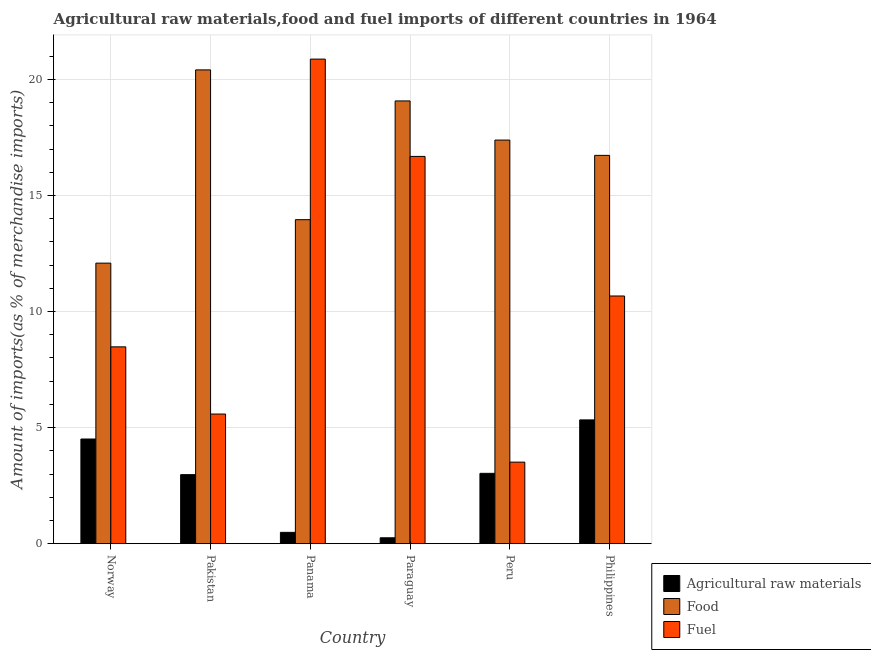How many groups of bars are there?
Your response must be concise. 6. Are the number of bars on each tick of the X-axis equal?
Offer a very short reply. Yes. What is the label of the 4th group of bars from the left?
Provide a succinct answer. Paraguay. What is the percentage of food imports in Norway?
Ensure brevity in your answer.  12.08. Across all countries, what is the maximum percentage of fuel imports?
Provide a short and direct response. 20.87. Across all countries, what is the minimum percentage of food imports?
Your answer should be compact. 12.08. In which country was the percentage of raw materials imports minimum?
Your answer should be very brief. Paraguay. What is the total percentage of food imports in the graph?
Your response must be concise. 99.63. What is the difference between the percentage of raw materials imports in Norway and that in Peru?
Offer a very short reply. 1.48. What is the difference between the percentage of raw materials imports in Paraguay and the percentage of food imports in Philippines?
Offer a terse response. -16.47. What is the average percentage of food imports per country?
Give a very brief answer. 16.61. What is the difference between the percentage of food imports and percentage of raw materials imports in Norway?
Make the answer very short. 7.58. What is the ratio of the percentage of food imports in Pakistan to that in Paraguay?
Keep it short and to the point. 1.07. Is the difference between the percentage of raw materials imports in Pakistan and Peru greater than the difference between the percentage of fuel imports in Pakistan and Peru?
Ensure brevity in your answer.  No. What is the difference between the highest and the second highest percentage of raw materials imports?
Keep it short and to the point. 0.82. What is the difference between the highest and the lowest percentage of food imports?
Your response must be concise. 8.32. What does the 2nd bar from the left in Philippines represents?
Make the answer very short. Food. What does the 2nd bar from the right in Norway represents?
Ensure brevity in your answer.  Food. Is it the case that in every country, the sum of the percentage of raw materials imports and percentage of food imports is greater than the percentage of fuel imports?
Offer a very short reply. No. Are all the bars in the graph horizontal?
Provide a short and direct response. No. How many countries are there in the graph?
Make the answer very short. 6. Are the values on the major ticks of Y-axis written in scientific E-notation?
Your answer should be compact. No. Does the graph contain grids?
Provide a short and direct response. Yes. What is the title of the graph?
Offer a terse response. Agricultural raw materials,food and fuel imports of different countries in 1964. What is the label or title of the X-axis?
Give a very brief answer. Country. What is the label or title of the Y-axis?
Your response must be concise. Amount of imports(as % of merchandise imports). What is the Amount of imports(as % of merchandise imports) of Agricultural raw materials in Norway?
Offer a very short reply. 4.51. What is the Amount of imports(as % of merchandise imports) in Food in Norway?
Your answer should be very brief. 12.08. What is the Amount of imports(as % of merchandise imports) of Fuel in Norway?
Ensure brevity in your answer.  8.48. What is the Amount of imports(as % of merchandise imports) in Agricultural raw materials in Pakistan?
Offer a very short reply. 2.97. What is the Amount of imports(as % of merchandise imports) of Food in Pakistan?
Offer a very short reply. 20.41. What is the Amount of imports(as % of merchandise imports) in Fuel in Pakistan?
Make the answer very short. 5.58. What is the Amount of imports(as % of merchandise imports) in Agricultural raw materials in Panama?
Offer a terse response. 0.49. What is the Amount of imports(as % of merchandise imports) in Food in Panama?
Offer a very short reply. 13.96. What is the Amount of imports(as % of merchandise imports) of Fuel in Panama?
Keep it short and to the point. 20.87. What is the Amount of imports(as % of merchandise imports) in Agricultural raw materials in Paraguay?
Offer a very short reply. 0.25. What is the Amount of imports(as % of merchandise imports) of Food in Paraguay?
Give a very brief answer. 19.07. What is the Amount of imports(as % of merchandise imports) in Fuel in Paraguay?
Provide a succinct answer. 16.68. What is the Amount of imports(as % of merchandise imports) of Agricultural raw materials in Peru?
Your answer should be compact. 3.03. What is the Amount of imports(as % of merchandise imports) of Food in Peru?
Make the answer very short. 17.39. What is the Amount of imports(as % of merchandise imports) in Fuel in Peru?
Keep it short and to the point. 3.51. What is the Amount of imports(as % of merchandise imports) in Agricultural raw materials in Philippines?
Provide a succinct answer. 5.33. What is the Amount of imports(as % of merchandise imports) of Food in Philippines?
Ensure brevity in your answer.  16.73. What is the Amount of imports(as % of merchandise imports) of Fuel in Philippines?
Give a very brief answer. 10.67. Across all countries, what is the maximum Amount of imports(as % of merchandise imports) in Agricultural raw materials?
Keep it short and to the point. 5.33. Across all countries, what is the maximum Amount of imports(as % of merchandise imports) in Food?
Make the answer very short. 20.41. Across all countries, what is the maximum Amount of imports(as % of merchandise imports) in Fuel?
Make the answer very short. 20.87. Across all countries, what is the minimum Amount of imports(as % of merchandise imports) in Agricultural raw materials?
Give a very brief answer. 0.25. Across all countries, what is the minimum Amount of imports(as % of merchandise imports) of Food?
Give a very brief answer. 12.08. Across all countries, what is the minimum Amount of imports(as % of merchandise imports) of Fuel?
Offer a very short reply. 3.51. What is the total Amount of imports(as % of merchandise imports) in Agricultural raw materials in the graph?
Make the answer very short. 16.58. What is the total Amount of imports(as % of merchandise imports) of Food in the graph?
Your answer should be compact. 99.63. What is the total Amount of imports(as % of merchandise imports) of Fuel in the graph?
Offer a very short reply. 65.8. What is the difference between the Amount of imports(as % of merchandise imports) in Agricultural raw materials in Norway and that in Pakistan?
Your answer should be compact. 1.53. What is the difference between the Amount of imports(as % of merchandise imports) of Food in Norway and that in Pakistan?
Make the answer very short. -8.32. What is the difference between the Amount of imports(as % of merchandise imports) of Fuel in Norway and that in Pakistan?
Keep it short and to the point. 2.89. What is the difference between the Amount of imports(as % of merchandise imports) in Agricultural raw materials in Norway and that in Panama?
Ensure brevity in your answer.  4.02. What is the difference between the Amount of imports(as % of merchandise imports) of Food in Norway and that in Panama?
Provide a short and direct response. -1.87. What is the difference between the Amount of imports(as % of merchandise imports) of Fuel in Norway and that in Panama?
Offer a terse response. -12.4. What is the difference between the Amount of imports(as % of merchandise imports) of Agricultural raw materials in Norway and that in Paraguay?
Provide a succinct answer. 4.26. What is the difference between the Amount of imports(as % of merchandise imports) of Food in Norway and that in Paraguay?
Offer a very short reply. -6.99. What is the difference between the Amount of imports(as % of merchandise imports) in Fuel in Norway and that in Paraguay?
Offer a terse response. -8.2. What is the difference between the Amount of imports(as % of merchandise imports) in Agricultural raw materials in Norway and that in Peru?
Ensure brevity in your answer.  1.48. What is the difference between the Amount of imports(as % of merchandise imports) of Food in Norway and that in Peru?
Provide a succinct answer. -5.3. What is the difference between the Amount of imports(as % of merchandise imports) of Fuel in Norway and that in Peru?
Your response must be concise. 4.97. What is the difference between the Amount of imports(as % of merchandise imports) of Agricultural raw materials in Norway and that in Philippines?
Keep it short and to the point. -0.82. What is the difference between the Amount of imports(as % of merchandise imports) in Food in Norway and that in Philippines?
Your answer should be very brief. -4.64. What is the difference between the Amount of imports(as % of merchandise imports) in Fuel in Norway and that in Philippines?
Give a very brief answer. -2.19. What is the difference between the Amount of imports(as % of merchandise imports) in Agricultural raw materials in Pakistan and that in Panama?
Give a very brief answer. 2.49. What is the difference between the Amount of imports(as % of merchandise imports) in Food in Pakistan and that in Panama?
Your answer should be compact. 6.45. What is the difference between the Amount of imports(as % of merchandise imports) of Fuel in Pakistan and that in Panama?
Give a very brief answer. -15.29. What is the difference between the Amount of imports(as % of merchandise imports) of Agricultural raw materials in Pakistan and that in Paraguay?
Your answer should be very brief. 2.72. What is the difference between the Amount of imports(as % of merchandise imports) of Food in Pakistan and that in Paraguay?
Your answer should be compact. 1.34. What is the difference between the Amount of imports(as % of merchandise imports) of Fuel in Pakistan and that in Paraguay?
Provide a short and direct response. -11.1. What is the difference between the Amount of imports(as % of merchandise imports) of Agricultural raw materials in Pakistan and that in Peru?
Offer a terse response. -0.06. What is the difference between the Amount of imports(as % of merchandise imports) in Food in Pakistan and that in Peru?
Your response must be concise. 3.02. What is the difference between the Amount of imports(as % of merchandise imports) in Fuel in Pakistan and that in Peru?
Your answer should be very brief. 2.07. What is the difference between the Amount of imports(as % of merchandise imports) of Agricultural raw materials in Pakistan and that in Philippines?
Your response must be concise. -2.36. What is the difference between the Amount of imports(as % of merchandise imports) of Food in Pakistan and that in Philippines?
Give a very brief answer. 3.68. What is the difference between the Amount of imports(as % of merchandise imports) of Fuel in Pakistan and that in Philippines?
Make the answer very short. -5.09. What is the difference between the Amount of imports(as % of merchandise imports) of Agricultural raw materials in Panama and that in Paraguay?
Offer a very short reply. 0.23. What is the difference between the Amount of imports(as % of merchandise imports) in Food in Panama and that in Paraguay?
Your answer should be compact. -5.12. What is the difference between the Amount of imports(as % of merchandise imports) of Fuel in Panama and that in Paraguay?
Keep it short and to the point. 4.19. What is the difference between the Amount of imports(as % of merchandise imports) in Agricultural raw materials in Panama and that in Peru?
Your answer should be very brief. -2.54. What is the difference between the Amount of imports(as % of merchandise imports) in Food in Panama and that in Peru?
Make the answer very short. -3.43. What is the difference between the Amount of imports(as % of merchandise imports) of Fuel in Panama and that in Peru?
Your answer should be very brief. 17.36. What is the difference between the Amount of imports(as % of merchandise imports) of Agricultural raw materials in Panama and that in Philippines?
Your response must be concise. -4.84. What is the difference between the Amount of imports(as % of merchandise imports) in Food in Panama and that in Philippines?
Provide a short and direct response. -2.77. What is the difference between the Amount of imports(as % of merchandise imports) in Fuel in Panama and that in Philippines?
Keep it short and to the point. 10.2. What is the difference between the Amount of imports(as % of merchandise imports) in Agricultural raw materials in Paraguay and that in Peru?
Provide a short and direct response. -2.78. What is the difference between the Amount of imports(as % of merchandise imports) of Food in Paraguay and that in Peru?
Make the answer very short. 1.69. What is the difference between the Amount of imports(as % of merchandise imports) in Fuel in Paraguay and that in Peru?
Provide a short and direct response. 13.17. What is the difference between the Amount of imports(as % of merchandise imports) of Agricultural raw materials in Paraguay and that in Philippines?
Offer a very short reply. -5.08. What is the difference between the Amount of imports(as % of merchandise imports) of Food in Paraguay and that in Philippines?
Your response must be concise. 2.35. What is the difference between the Amount of imports(as % of merchandise imports) in Fuel in Paraguay and that in Philippines?
Ensure brevity in your answer.  6.01. What is the difference between the Amount of imports(as % of merchandise imports) of Agricultural raw materials in Peru and that in Philippines?
Your response must be concise. -2.3. What is the difference between the Amount of imports(as % of merchandise imports) of Food in Peru and that in Philippines?
Ensure brevity in your answer.  0.66. What is the difference between the Amount of imports(as % of merchandise imports) in Fuel in Peru and that in Philippines?
Your answer should be compact. -7.16. What is the difference between the Amount of imports(as % of merchandise imports) in Agricultural raw materials in Norway and the Amount of imports(as % of merchandise imports) in Food in Pakistan?
Your answer should be very brief. -15.9. What is the difference between the Amount of imports(as % of merchandise imports) in Agricultural raw materials in Norway and the Amount of imports(as % of merchandise imports) in Fuel in Pakistan?
Give a very brief answer. -1.08. What is the difference between the Amount of imports(as % of merchandise imports) in Food in Norway and the Amount of imports(as % of merchandise imports) in Fuel in Pakistan?
Give a very brief answer. 6.5. What is the difference between the Amount of imports(as % of merchandise imports) of Agricultural raw materials in Norway and the Amount of imports(as % of merchandise imports) of Food in Panama?
Provide a succinct answer. -9.45. What is the difference between the Amount of imports(as % of merchandise imports) of Agricultural raw materials in Norway and the Amount of imports(as % of merchandise imports) of Fuel in Panama?
Your answer should be compact. -16.37. What is the difference between the Amount of imports(as % of merchandise imports) of Food in Norway and the Amount of imports(as % of merchandise imports) of Fuel in Panama?
Your response must be concise. -8.79. What is the difference between the Amount of imports(as % of merchandise imports) in Agricultural raw materials in Norway and the Amount of imports(as % of merchandise imports) in Food in Paraguay?
Your response must be concise. -14.56. What is the difference between the Amount of imports(as % of merchandise imports) in Agricultural raw materials in Norway and the Amount of imports(as % of merchandise imports) in Fuel in Paraguay?
Your response must be concise. -12.17. What is the difference between the Amount of imports(as % of merchandise imports) of Food in Norway and the Amount of imports(as % of merchandise imports) of Fuel in Paraguay?
Make the answer very short. -4.6. What is the difference between the Amount of imports(as % of merchandise imports) of Agricultural raw materials in Norway and the Amount of imports(as % of merchandise imports) of Food in Peru?
Your response must be concise. -12.88. What is the difference between the Amount of imports(as % of merchandise imports) in Food in Norway and the Amount of imports(as % of merchandise imports) in Fuel in Peru?
Ensure brevity in your answer.  8.57. What is the difference between the Amount of imports(as % of merchandise imports) in Agricultural raw materials in Norway and the Amount of imports(as % of merchandise imports) in Food in Philippines?
Give a very brief answer. -12.22. What is the difference between the Amount of imports(as % of merchandise imports) in Agricultural raw materials in Norway and the Amount of imports(as % of merchandise imports) in Fuel in Philippines?
Keep it short and to the point. -6.16. What is the difference between the Amount of imports(as % of merchandise imports) of Food in Norway and the Amount of imports(as % of merchandise imports) of Fuel in Philippines?
Provide a succinct answer. 1.42. What is the difference between the Amount of imports(as % of merchandise imports) of Agricultural raw materials in Pakistan and the Amount of imports(as % of merchandise imports) of Food in Panama?
Your answer should be compact. -10.98. What is the difference between the Amount of imports(as % of merchandise imports) in Agricultural raw materials in Pakistan and the Amount of imports(as % of merchandise imports) in Fuel in Panama?
Offer a very short reply. -17.9. What is the difference between the Amount of imports(as % of merchandise imports) of Food in Pakistan and the Amount of imports(as % of merchandise imports) of Fuel in Panama?
Your answer should be very brief. -0.46. What is the difference between the Amount of imports(as % of merchandise imports) in Agricultural raw materials in Pakistan and the Amount of imports(as % of merchandise imports) in Food in Paraguay?
Your answer should be compact. -16.1. What is the difference between the Amount of imports(as % of merchandise imports) of Agricultural raw materials in Pakistan and the Amount of imports(as % of merchandise imports) of Fuel in Paraguay?
Ensure brevity in your answer.  -13.71. What is the difference between the Amount of imports(as % of merchandise imports) of Food in Pakistan and the Amount of imports(as % of merchandise imports) of Fuel in Paraguay?
Offer a very short reply. 3.73. What is the difference between the Amount of imports(as % of merchandise imports) of Agricultural raw materials in Pakistan and the Amount of imports(as % of merchandise imports) of Food in Peru?
Provide a succinct answer. -14.41. What is the difference between the Amount of imports(as % of merchandise imports) in Agricultural raw materials in Pakistan and the Amount of imports(as % of merchandise imports) in Fuel in Peru?
Make the answer very short. -0.54. What is the difference between the Amount of imports(as % of merchandise imports) of Food in Pakistan and the Amount of imports(as % of merchandise imports) of Fuel in Peru?
Offer a very short reply. 16.9. What is the difference between the Amount of imports(as % of merchandise imports) in Agricultural raw materials in Pakistan and the Amount of imports(as % of merchandise imports) in Food in Philippines?
Provide a succinct answer. -13.75. What is the difference between the Amount of imports(as % of merchandise imports) in Agricultural raw materials in Pakistan and the Amount of imports(as % of merchandise imports) in Fuel in Philippines?
Offer a very short reply. -7.7. What is the difference between the Amount of imports(as % of merchandise imports) in Food in Pakistan and the Amount of imports(as % of merchandise imports) in Fuel in Philippines?
Provide a succinct answer. 9.74. What is the difference between the Amount of imports(as % of merchandise imports) in Agricultural raw materials in Panama and the Amount of imports(as % of merchandise imports) in Food in Paraguay?
Your response must be concise. -18.58. What is the difference between the Amount of imports(as % of merchandise imports) of Agricultural raw materials in Panama and the Amount of imports(as % of merchandise imports) of Fuel in Paraguay?
Your answer should be very brief. -16.19. What is the difference between the Amount of imports(as % of merchandise imports) of Food in Panama and the Amount of imports(as % of merchandise imports) of Fuel in Paraguay?
Make the answer very short. -2.73. What is the difference between the Amount of imports(as % of merchandise imports) of Agricultural raw materials in Panama and the Amount of imports(as % of merchandise imports) of Food in Peru?
Keep it short and to the point. -16.9. What is the difference between the Amount of imports(as % of merchandise imports) of Agricultural raw materials in Panama and the Amount of imports(as % of merchandise imports) of Fuel in Peru?
Offer a terse response. -3.02. What is the difference between the Amount of imports(as % of merchandise imports) of Food in Panama and the Amount of imports(as % of merchandise imports) of Fuel in Peru?
Offer a very short reply. 10.44. What is the difference between the Amount of imports(as % of merchandise imports) of Agricultural raw materials in Panama and the Amount of imports(as % of merchandise imports) of Food in Philippines?
Ensure brevity in your answer.  -16.24. What is the difference between the Amount of imports(as % of merchandise imports) of Agricultural raw materials in Panama and the Amount of imports(as % of merchandise imports) of Fuel in Philippines?
Your answer should be very brief. -10.18. What is the difference between the Amount of imports(as % of merchandise imports) in Food in Panama and the Amount of imports(as % of merchandise imports) in Fuel in Philippines?
Provide a short and direct response. 3.29. What is the difference between the Amount of imports(as % of merchandise imports) of Agricultural raw materials in Paraguay and the Amount of imports(as % of merchandise imports) of Food in Peru?
Keep it short and to the point. -17.13. What is the difference between the Amount of imports(as % of merchandise imports) of Agricultural raw materials in Paraguay and the Amount of imports(as % of merchandise imports) of Fuel in Peru?
Make the answer very short. -3.26. What is the difference between the Amount of imports(as % of merchandise imports) of Food in Paraguay and the Amount of imports(as % of merchandise imports) of Fuel in Peru?
Keep it short and to the point. 15.56. What is the difference between the Amount of imports(as % of merchandise imports) of Agricultural raw materials in Paraguay and the Amount of imports(as % of merchandise imports) of Food in Philippines?
Your answer should be compact. -16.47. What is the difference between the Amount of imports(as % of merchandise imports) in Agricultural raw materials in Paraguay and the Amount of imports(as % of merchandise imports) in Fuel in Philippines?
Make the answer very short. -10.42. What is the difference between the Amount of imports(as % of merchandise imports) in Food in Paraguay and the Amount of imports(as % of merchandise imports) in Fuel in Philippines?
Ensure brevity in your answer.  8.4. What is the difference between the Amount of imports(as % of merchandise imports) of Agricultural raw materials in Peru and the Amount of imports(as % of merchandise imports) of Food in Philippines?
Provide a succinct answer. -13.7. What is the difference between the Amount of imports(as % of merchandise imports) of Agricultural raw materials in Peru and the Amount of imports(as % of merchandise imports) of Fuel in Philippines?
Offer a terse response. -7.64. What is the difference between the Amount of imports(as % of merchandise imports) of Food in Peru and the Amount of imports(as % of merchandise imports) of Fuel in Philippines?
Your answer should be compact. 6.72. What is the average Amount of imports(as % of merchandise imports) of Agricultural raw materials per country?
Give a very brief answer. 2.76. What is the average Amount of imports(as % of merchandise imports) in Food per country?
Ensure brevity in your answer.  16.61. What is the average Amount of imports(as % of merchandise imports) in Fuel per country?
Make the answer very short. 10.97. What is the difference between the Amount of imports(as % of merchandise imports) of Agricultural raw materials and Amount of imports(as % of merchandise imports) of Food in Norway?
Make the answer very short. -7.58. What is the difference between the Amount of imports(as % of merchandise imports) of Agricultural raw materials and Amount of imports(as % of merchandise imports) of Fuel in Norway?
Keep it short and to the point. -3.97. What is the difference between the Amount of imports(as % of merchandise imports) of Food and Amount of imports(as % of merchandise imports) of Fuel in Norway?
Provide a short and direct response. 3.61. What is the difference between the Amount of imports(as % of merchandise imports) in Agricultural raw materials and Amount of imports(as % of merchandise imports) in Food in Pakistan?
Offer a very short reply. -17.44. What is the difference between the Amount of imports(as % of merchandise imports) in Agricultural raw materials and Amount of imports(as % of merchandise imports) in Fuel in Pakistan?
Ensure brevity in your answer.  -2.61. What is the difference between the Amount of imports(as % of merchandise imports) in Food and Amount of imports(as % of merchandise imports) in Fuel in Pakistan?
Offer a very short reply. 14.83. What is the difference between the Amount of imports(as % of merchandise imports) of Agricultural raw materials and Amount of imports(as % of merchandise imports) of Food in Panama?
Your answer should be very brief. -13.47. What is the difference between the Amount of imports(as % of merchandise imports) in Agricultural raw materials and Amount of imports(as % of merchandise imports) in Fuel in Panama?
Your answer should be very brief. -20.39. What is the difference between the Amount of imports(as % of merchandise imports) in Food and Amount of imports(as % of merchandise imports) in Fuel in Panama?
Your response must be concise. -6.92. What is the difference between the Amount of imports(as % of merchandise imports) of Agricultural raw materials and Amount of imports(as % of merchandise imports) of Food in Paraguay?
Offer a terse response. -18.82. What is the difference between the Amount of imports(as % of merchandise imports) in Agricultural raw materials and Amount of imports(as % of merchandise imports) in Fuel in Paraguay?
Make the answer very short. -16.43. What is the difference between the Amount of imports(as % of merchandise imports) in Food and Amount of imports(as % of merchandise imports) in Fuel in Paraguay?
Keep it short and to the point. 2.39. What is the difference between the Amount of imports(as % of merchandise imports) in Agricultural raw materials and Amount of imports(as % of merchandise imports) in Food in Peru?
Your response must be concise. -14.36. What is the difference between the Amount of imports(as % of merchandise imports) of Agricultural raw materials and Amount of imports(as % of merchandise imports) of Fuel in Peru?
Your answer should be compact. -0.48. What is the difference between the Amount of imports(as % of merchandise imports) in Food and Amount of imports(as % of merchandise imports) in Fuel in Peru?
Your response must be concise. 13.87. What is the difference between the Amount of imports(as % of merchandise imports) of Agricultural raw materials and Amount of imports(as % of merchandise imports) of Food in Philippines?
Offer a very short reply. -11.39. What is the difference between the Amount of imports(as % of merchandise imports) of Agricultural raw materials and Amount of imports(as % of merchandise imports) of Fuel in Philippines?
Ensure brevity in your answer.  -5.34. What is the difference between the Amount of imports(as % of merchandise imports) in Food and Amount of imports(as % of merchandise imports) in Fuel in Philippines?
Make the answer very short. 6.06. What is the ratio of the Amount of imports(as % of merchandise imports) in Agricultural raw materials in Norway to that in Pakistan?
Offer a terse response. 1.52. What is the ratio of the Amount of imports(as % of merchandise imports) of Food in Norway to that in Pakistan?
Offer a terse response. 0.59. What is the ratio of the Amount of imports(as % of merchandise imports) of Fuel in Norway to that in Pakistan?
Make the answer very short. 1.52. What is the ratio of the Amount of imports(as % of merchandise imports) of Agricultural raw materials in Norway to that in Panama?
Offer a terse response. 9.26. What is the ratio of the Amount of imports(as % of merchandise imports) of Food in Norway to that in Panama?
Keep it short and to the point. 0.87. What is the ratio of the Amount of imports(as % of merchandise imports) of Fuel in Norway to that in Panama?
Ensure brevity in your answer.  0.41. What is the ratio of the Amount of imports(as % of merchandise imports) of Agricultural raw materials in Norway to that in Paraguay?
Keep it short and to the point. 17.83. What is the ratio of the Amount of imports(as % of merchandise imports) of Food in Norway to that in Paraguay?
Offer a terse response. 0.63. What is the ratio of the Amount of imports(as % of merchandise imports) of Fuel in Norway to that in Paraguay?
Offer a very short reply. 0.51. What is the ratio of the Amount of imports(as % of merchandise imports) in Agricultural raw materials in Norway to that in Peru?
Offer a terse response. 1.49. What is the ratio of the Amount of imports(as % of merchandise imports) in Food in Norway to that in Peru?
Give a very brief answer. 0.7. What is the ratio of the Amount of imports(as % of merchandise imports) of Fuel in Norway to that in Peru?
Provide a short and direct response. 2.41. What is the ratio of the Amount of imports(as % of merchandise imports) of Agricultural raw materials in Norway to that in Philippines?
Offer a terse response. 0.85. What is the ratio of the Amount of imports(as % of merchandise imports) of Food in Norway to that in Philippines?
Your answer should be very brief. 0.72. What is the ratio of the Amount of imports(as % of merchandise imports) in Fuel in Norway to that in Philippines?
Provide a short and direct response. 0.79. What is the ratio of the Amount of imports(as % of merchandise imports) of Agricultural raw materials in Pakistan to that in Panama?
Make the answer very short. 6.11. What is the ratio of the Amount of imports(as % of merchandise imports) of Food in Pakistan to that in Panama?
Your response must be concise. 1.46. What is the ratio of the Amount of imports(as % of merchandise imports) of Fuel in Pakistan to that in Panama?
Provide a succinct answer. 0.27. What is the ratio of the Amount of imports(as % of merchandise imports) in Agricultural raw materials in Pakistan to that in Paraguay?
Provide a short and direct response. 11.76. What is the ratio of the Amount of imports(as % of merchandise imports) of Food in Pakistan to that in Paraguay?
Give a very brief answer. 1.07. What is the ratio of the Amount of imports(as % of merchandise imports) in Fuel in Pakistan to that in Paraguay?
Your response must be concise. 0.33. What is the ratio of the Amount of imports(as % of merchandise imports) of Agricultural raw materials in Pakistan to that in Peru?
Provide a succinct answer. 0.98. What is the ratio of the Amount of imports(as % of merchandise imports) of Food in Pakistan to that in Peru?
Your answer should be very brief. 1.17. What is the ratio of the Amount of imports(as % of merchandise imports) in Fuel in Pakistan to that in Peru?
Your answer should be very brief. 1.59. What is the ratio of the Amount of imports(as % of merchandise imports) of Agricultural raw materials in Pakistan to that in Philippines?
Keep it short and to the point. 0.56. What is the ratio of the Amount of imports(as % of merchandise imports) in Food in Pakistan to that in Philippines?
Your answer should be very brief. 1.22. What is the ratio of the Amount of imports(as % of merchandise imports) in Fuel in Pakistan to that in Philippines?
Give a very brief answer. 0.52. What is the ratio of the Amount of imports(as % of merchandise imports) in Agricultural raw materials in Panama to that in Paraguay?
Make the answer very short. 1.93. What is the ratio of the Amount of imports(as % of merchandise imports) of Food in Panama to that in Paraguay?
Keep it short and to the point. 0.73. What is the ratio of the Amount of imports(as % of merchandise imports) of Fuel in Panama to that in Paraguay?
Your answer should be very brief. 1.25. What is the ratio of the Amount of imports(as % of merchandise imports) in Agricultural raw materials in Panama to that in Peru?
Provide a short and direct response. 0.16. What is the ratio of the Amount of imports(as % of merchandise imports) in Food in Panama to that in Peru?
Offer a very short reply. 0.8. What is the ratio of the Amount of imports(as % of merchandise imports) in Fuel in Panama to that in Peru?
Offer a very short reply. 5.94. What is the ratio of the Amount of imports(as % of merchandise imports) of Agricultural raw materials in Panama to that in Philippines?
Provide a succinct answer. 0.09. What is the ratio of the Amount of imports(as % of merchandise imports) in Food in Panama to that in Philippines?
Your response must be concise. 0.83. What is the ratio of the Amount of imports(as % of merchandise imports) of Fuel in Panama to that in Philippines?
Make the answer very short. 1.96. What is the ratio of the Amount of imports(as % of merchandise imports) in Agricultural raw materials in Paraguay to that in Peru?
Provide a succinct answer. 0.08. What is the ratio of the Amount of imports(as % of merchandise imports) of Food in Paraguay to that in Peru?
Your response must be concise. 1.1. What is the ratio of the Amount of imports(as % of merchandise imports) of Fuel in Paraguay to that in Peru?
Provide a short and direct response. 4.75. What is the ratio of the Amount of imports(as % of merchandise imports) in Agricultural raw materials in Paraguay to that in Philippines?
Offer a very short reply. 0.05. What is the ratio of the Amount of imports(as % of merchandise imports) of Food in Paraguay to that in Philippines?
Give a very brief answer. 1.14. What is the ratio of the Amount of imports(as % of merchandise imports) of Fuel in Paraguay to that in Philippines?
Keep it short and to the point. 1.56. What is the ratio of the Amount of imports(as % of merchandise imports) of Agricultural raw materials in Peru to that in Philippines?
Ensure brevity in your answer.  0.57. What is the ratio of the Amount of imports(as % of merchandise imports) in Food in Peru to that in Philippines?
Ensure brevity in your answer.  1.04. What is the ratio of the Amount of imports(as % of merchandise imports) in Fuel in Peru to that in Philippines?
Your answer should be very brief. 0.33. What is the difference between the highest and the second highest Amount of imports(as % of merchandise imports) in Agricultural raw materials?
Your answer should be very brief. 0.82. What is the difference between the highest and the second highest Amount of imports(as % of merchandise imports) in Food?
Offer a terse response. 1.34. What is the difference between the highest and the second highest Amount of imports(as % of merchandise imports) of Fuel?
Provide a succinct answer. 4.19. What is the difference between the highest and the lowest Amount of imports(as % of merchandise imports) in Agricultural raw materials?
Provide a short and direct response. 5.08. What is the difference between the highest and the lowest Amount of imports(as % of merchandise imports) in Food?
Make the answer very short. 8.32. What is the difference between the highest and the lowest Amount of imports(as % of merchandise imports) of Fuel?
Offer a terse response. 17.36. 